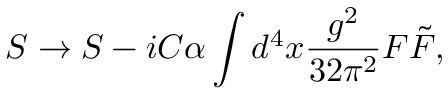Convert formula to latex. <formula><loc_0><loc_0><loc_500><loc_500>S \to S - i C \alpha \int d ^ { 4 } x \frac { g ^ { 2 } } { 3 2 \pi ^ { 2 } } F \tilde { F } ,</formula> 